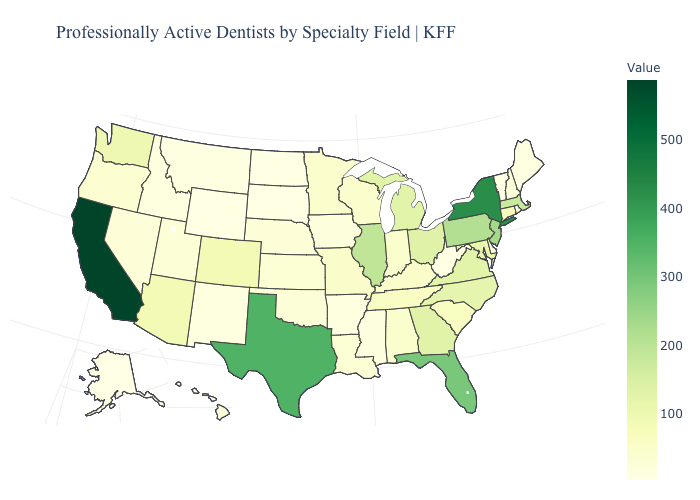Which states have the lowest value in the South?
Keep it brief. West Virginia. Does New Jersey have a higher value than Texas?
Be succinct. No. Does Pennsylvania have a higher value than Indiana?
Concise answer only. Yes. Among the states that border Rhode Island , which have the lowest value?
Short answer required. Connecticut. Which states have the lowest value in the South?
Answer briefly. West Virginia. 